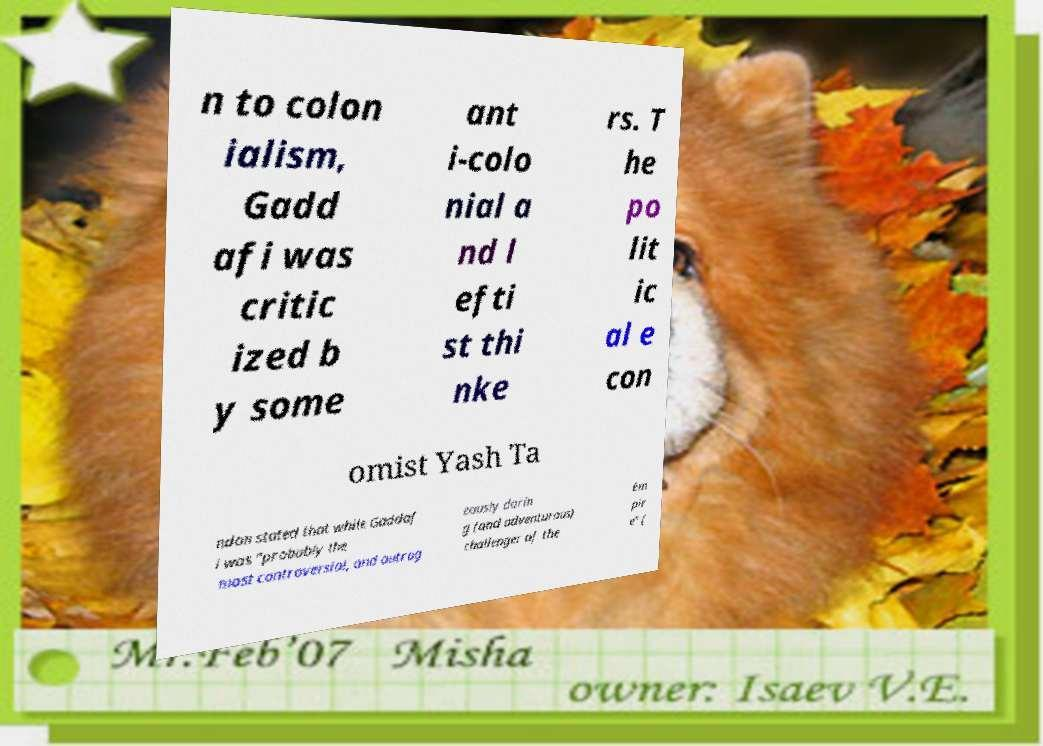Could you assist in decoding the text presented in this image and type it out clearly? n to colon ialism, Gadd afi was critic ized b y some ant i-colo nial a nd l efti st thi nke rs. T he po lit ic al e con omist Yash Ta ndon stated that while Gaddaf i was "probably the most controversial, and outrag eously darin g (and adventurous) challenger of the Em pir e" ( 